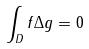<formula> <loc_0><loc_0><loc_500><loc_500>\int _ { D } f \Delta g = 0</formula> 